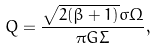<formula> <loc_0><loc_0><loc_500><loc_500>Q = \frac { \sqrt { 2 ( \beta + 1 ) } \sigma \Omega } { \pi G \Sigma } ,</formula> 